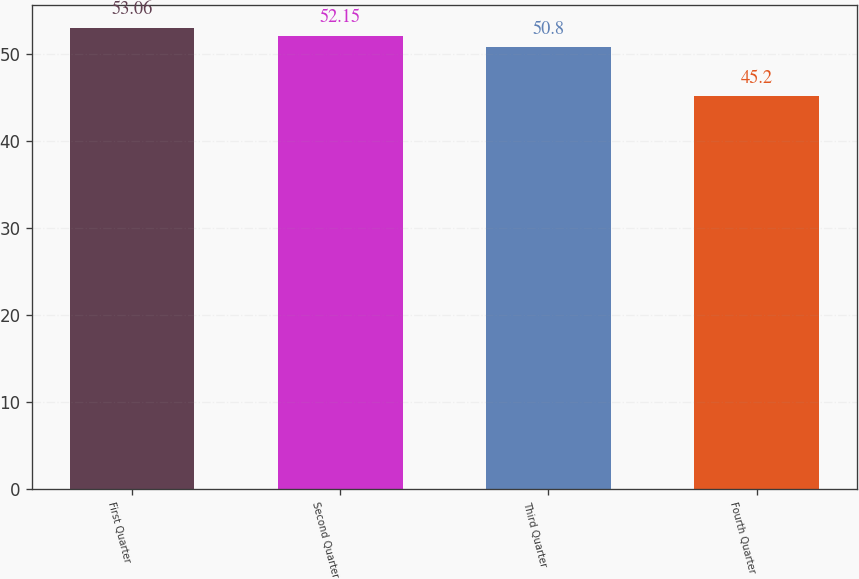<chart> <loc_0><loc_0><loc_500><loc_500><bar_chart><fcel>First Quarter<fcel>Second Quarter<fcel>Third Quarter<fcel>Fourth Quarter<nl><fcel>53.06<fcel>52.15<fcel>50.8<fcel>45.2<nl></chart> 